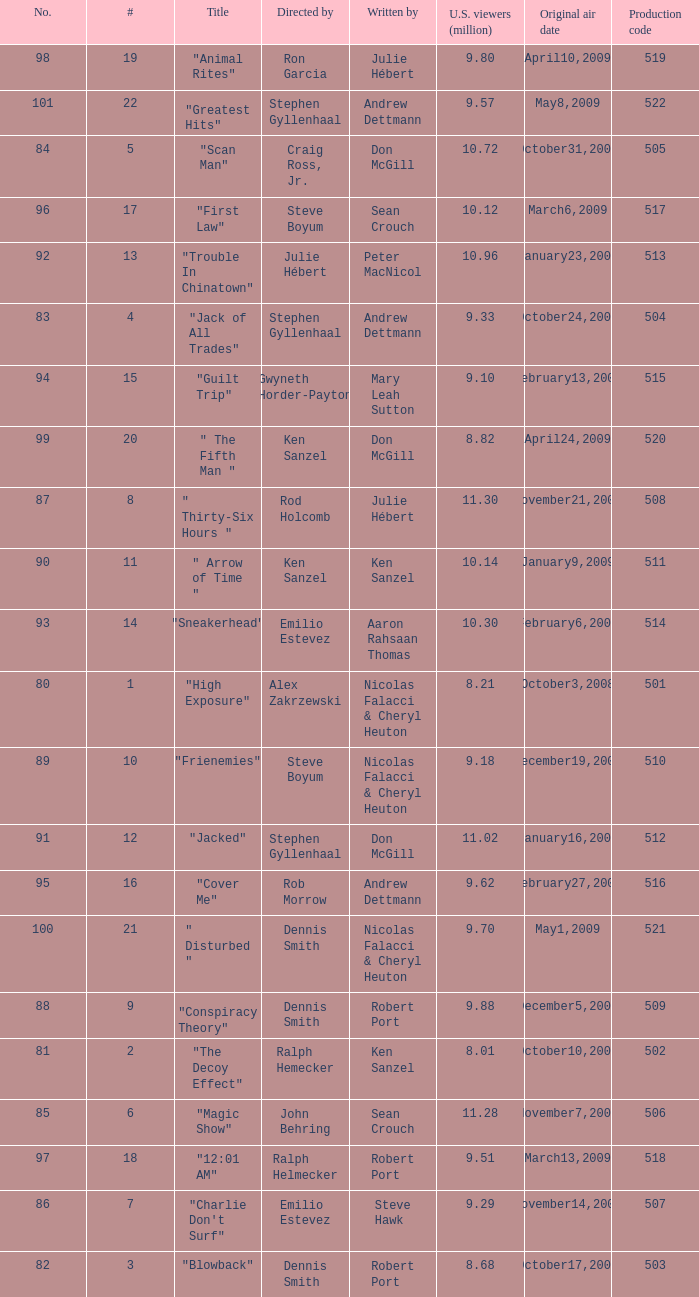Who wrote the episode with the production code 519? Julie Hébert. Parse the full table. {'header': ['No.', '#', 'Title', 'Directed by', 'Written by', 'U.S. viewers (million)', 'Original air date', 'Production code'], 'rows': [['98', '19', '"Animal Rites"', 'Ron Garcia', 'Julie Hébert', '9.80', 'April10,2009', '519'], ['101', '22', '"Greatest Hits"', 'Stephen Gyllenhaal', 'Andrew Dettmann', '9.57', 'May8,2009', '522'], ['84', '5', '"Scan Man"', 'Craig Ross, Jr.', 'Don McGill', '10.72', 'October31,2008', '505'], ['96', '17', '"First Law"', 'Steve Boyum', 'Sean Crouch', '10.12', 'March6,2009', '517'], ['92', '13', '"Trouble In Chinatown"', 'Julie Hébert', 'Peter MacNicol', '10.96', 'January23,2009', '513'], ['83', '4', '"Jack of All Trades"', 'Stephen Gyllenhaal', 'Andrew Dettmann', '9.33', 'October24,2008', '504'], ['94', '15', '"Guilt Trip"', 'Gwyneth Horder-Payton', 'Mary Leah Sutton', '9.10', 'February13,2009', '515'], ['99', '20', '" The Fifth Man "', 'Ken Sanzel', 'Don McGill', '8.82', 'April24,2009', '520'], ['87', '8', '" Thirty-Six Hours "', 'Rod Holcomb', 'Julie Hébert', '11.30', 'November21,2008', '508'], ['90', '11', '" Arrow of Time "', 'Ken Sanzel', 'Ken Sanzel', '10.14', 'January9,2009', '511'], ['93', '14', '"Sneakerhead"', 'Emilio Estevez', 'Aaron Rahsaan Thomas', '10.30', 'February6,2009', '514'], ['80', '1', '"High Exposure"', 'Alex Zakrzewski', 'Nicolas Falacci & Cheryl Heuton', '8.21', 'October3,2008', '501'], ['89', '10', '"Frienemies"', 'Steve Boyum', 'Nicolas Falacci & Cheryl Heuton', '9.18', 'December19,2008', '510'], ['91', '12', '"Jacked"', 'Stephen Gyllenhaal', 'Don McGill', '11.02', 'January16,2009', '512'], ['95', '16', '"Cover Me"', 'Rob Morrow', 'Andrew Dettmann', '9.62', 'February27,2009', '516'], ['100', '21', '" Disturbed "', 'Dennis Smith', 'Nicolas Falacci & Cheryl Heuton', '9.70', 'May1,2009', '521'], ['88', '9', '"Conspiracy Theory"', 'Dennis Smith', 'Robert Port', '9.88', 'December5,2008', '509'], ['81', '2', '"The Decoy Effect"', 'Ralph Hemecker', 'Ken Sanzel', '8.01', 'October10,2008', '502'], ['85', '6', '"Magic Show"', 'John Behring', 'Sean Crouch', '11.28', 'November7,2008', '506'], ['97', '18', '"12:01 AM"', 'Ralph Helmecker', 'Robert Port', '9.51', 'March13,2009', '518'], ['86', '7', '"Charlie Don\'t Surf"', 'Emilio Estevez', 'Steve Hawk', '9.29', 'November14,2008', '507'], ['82', '3', '"Blowback"', 'Dennis Smith', 'Robert Port', '8.68', 'October17,2008', '503']]} 